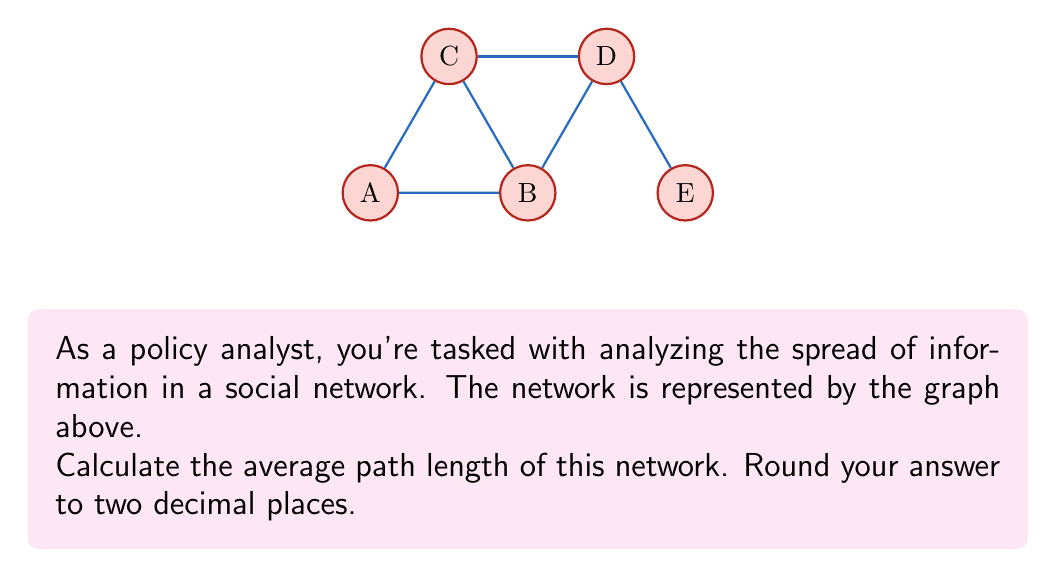Provide a solution to this math problem. To solve this problem, we need to follow these steps:

1) First, let's understand what average path length means. It's the average number of steps along the shortest paths for all possible pairs of network nodes.

2) We need to calculate the shortest path between every pair of nodes:

   A-B: 1
   A-C: 1
   A-D: 2
   A-E: 3
   B-C: 1
   B-D: 1
   B-E: 2
   C-D: 1
   C-E: 2
   D-E: 1

3) Now, we sum up all these path lengths:
   
   1 + 1 + 2 + 3 + 1 + 1 + 2 + 1 + 2 + 1 = 15

4) To get the average, we need to divide by the number of pairs. In a network with n nodes, the number of pairs is $\frac{n(n-1)}{2}$. Here, n = 5.

   Number of pairs = $\frac{5(5-1)}{2} = \frac{5 \times 4}{2} = 10$

5) Now we can calculate the average path length:

   Average path length = $\frac{15}{10} = 1.5$

6) The question asks for the result rounded to two decimal places, but 1.5 already satisfies this requirement.
Answer: 1.50 